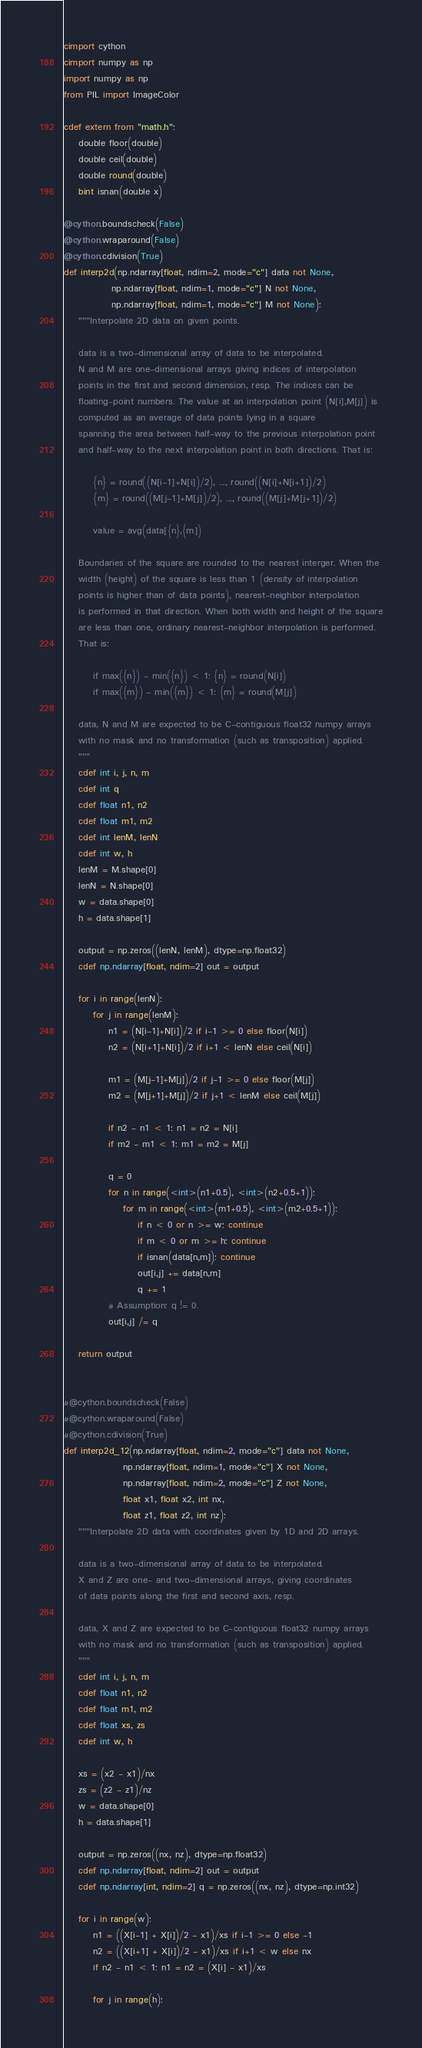<code> <loc_0><loc_0><loc_500><loc_500><_Cython_>cimport cython
cimport numpy as np
import numpy as np
from PIL import ImageColor

cdef extern from "math.h":
    double floor(double)
    double ceil(double)
    double round(double)
    bint isnan(double x)

@cython.boundscheck(False)
@cython.wraparound(False)
@cython.cdivision(True)
def interp2d(np.ndarray[float, ndim=2, mode="c"] data not None,
             np.ndarray[float, ndim=1, mode="c"] N not None,
             np.ndarray[float, ndim=1, mode="c"] M not None):
    """Interpolate 2D data on given points.

    data is a two-dimensional array of data to be interpolated.
    N and M are one-dimensional arrays giving indices of interpolation
    points in the first and second dimension, resp. The indices can be
    floating-point numbers. The value at an interpolation point (N[i],M[j]) is
    computed as an average of data points lying in a square
    spanning the area between half-way to the previous interpolation point
    and half-way to the next interpolation point in both directions. That is:

        {n} = round((N[i-1]+N[i])/2), ..., round((N[i]+N[i+1])/2)
        {m} = round((M[j-1]+M[j])/2), ..., round((M[j]+M[j+1])/2)

        value = avg(data[{n},{m])

    Boundaries of the square are rounded to the nearest interger. When the
    width (height) of the square is less than 1 (density of interpolation
    points is higher than of data points), nearest-neighbor interpolation
    is performed in that direction. When both width and height of the square
    are less than one, ordinary nearest-neighbor interpolation is performed.
    That is:

        if max({n}) - min({n}) < 1: {n} = round(N[i])
        if max({m}) - min({m}) < 1: {m} = round(M[j])

    data, N and M are expected to be C-contiguous float32 numpy arrays
    with no mask and no transformation (such as transposition) applied.
    """
    cdef int i, j, n, m
    cdef int q
    cdef float n1, n2
    cdef float m1, m2
    cdef int lenM, lenN
    cdef int w, h
    lenM = M.shape[0]
    lenN = N.shape[0]
    w = data.shape[0]
    h = data.shape[1]

    output = np.zeros((lenN, lenM), dtype=np.float32)
    cdef np.ndarray[float, ndim=2] out = output

    for i in range(lenN):
        for j in range(lenM):
            n1 = (N[i-1]+N[i])/2 if i-1 >= 0 else floor(N[i])
            n2 = (N[i+1]+N[i])/2 if i+1 < lenN else ceil(N[i])

            m1 = (M[j-1]+M[j])/2 if j-1 >= 0 else floor(M[j])
            m2 = (M[j+1]+M[j])/2 if j+1 < lenM else ceil(M[j])

            if n2 - n1 < 1: n1 = n2 = N[i]
            if m2 - m1 < 1: m1 = m2 = M[j]

            q = 0
            for n in range(<int>(n1+0.5), <int>(n2+0.5+1)):
                for m in range(<int>(m1+0.5), <int>(m2+0.5+1)):
                    if n < 0 or n >= w: continue
                    if m < 0 or m >= h: continue
                    if isnan(data[n,m]): continue
                    out[i,j] += data[n,m]
                    q += 1
            # Assumption: q != 0.
            out[i,j] /= q

    return output


#@cython.boundscheck(False)
#@cython.wraparound(False)
#@cython.cdivision(True)
def interp2d_12(np.ndarray[float, ndim=2, mode="c"] data not None,
                np.ndarray[float, ndim=1, mode="c"] X not None,
                np.ndarray[float, ndim=2, mode="c"] Z not None,
                float x1, float x2, int nx,
                float z1, float z2, int nz):
    """Interpolate 2D data with coordinates given by 1D and 2D arrays.

    data is a two-dimensional array of data to be interpolated.
    X and Z are one- and two-dimensional arrays, giving coordinates
    of data points along the first and second axis, resp.

    data, X and Z are expected to be C-contiguous float32 numpy arrays
    with no mask and no transformation (such as transposition) applied.
    """
    cdef int i, j, n, m
    cdef float n1, n2
    cdef float m1, m2
    cdef float xs, zs
    cdef int w, h

    xs = (x2 - x1)/nx
    zs = (z2 - z1)/nz
    w = data.shape[0]
    h = data.shape[1]

    output = np.zeros((nx, nz), dtype=np.float32)
    cdef np.ndarray[float, ndim=2] out = output
    cdef np.ndarray[int, ndim=2] q = np.zeros((nx, nz), dtype=np.int32)

    for i in range(w):
        n1 = ((X[i-1] + X[i])/2 - x1)/xs if i-1 >= 0 else -1
        n2 = ((X[i+1] + X[i])/2 - x1)/xs if i+1 < w else nx
        if n2 - n1 < 1: n1 = n2 = (X[i] - x1)/xs

        for j in range(h):</code> 